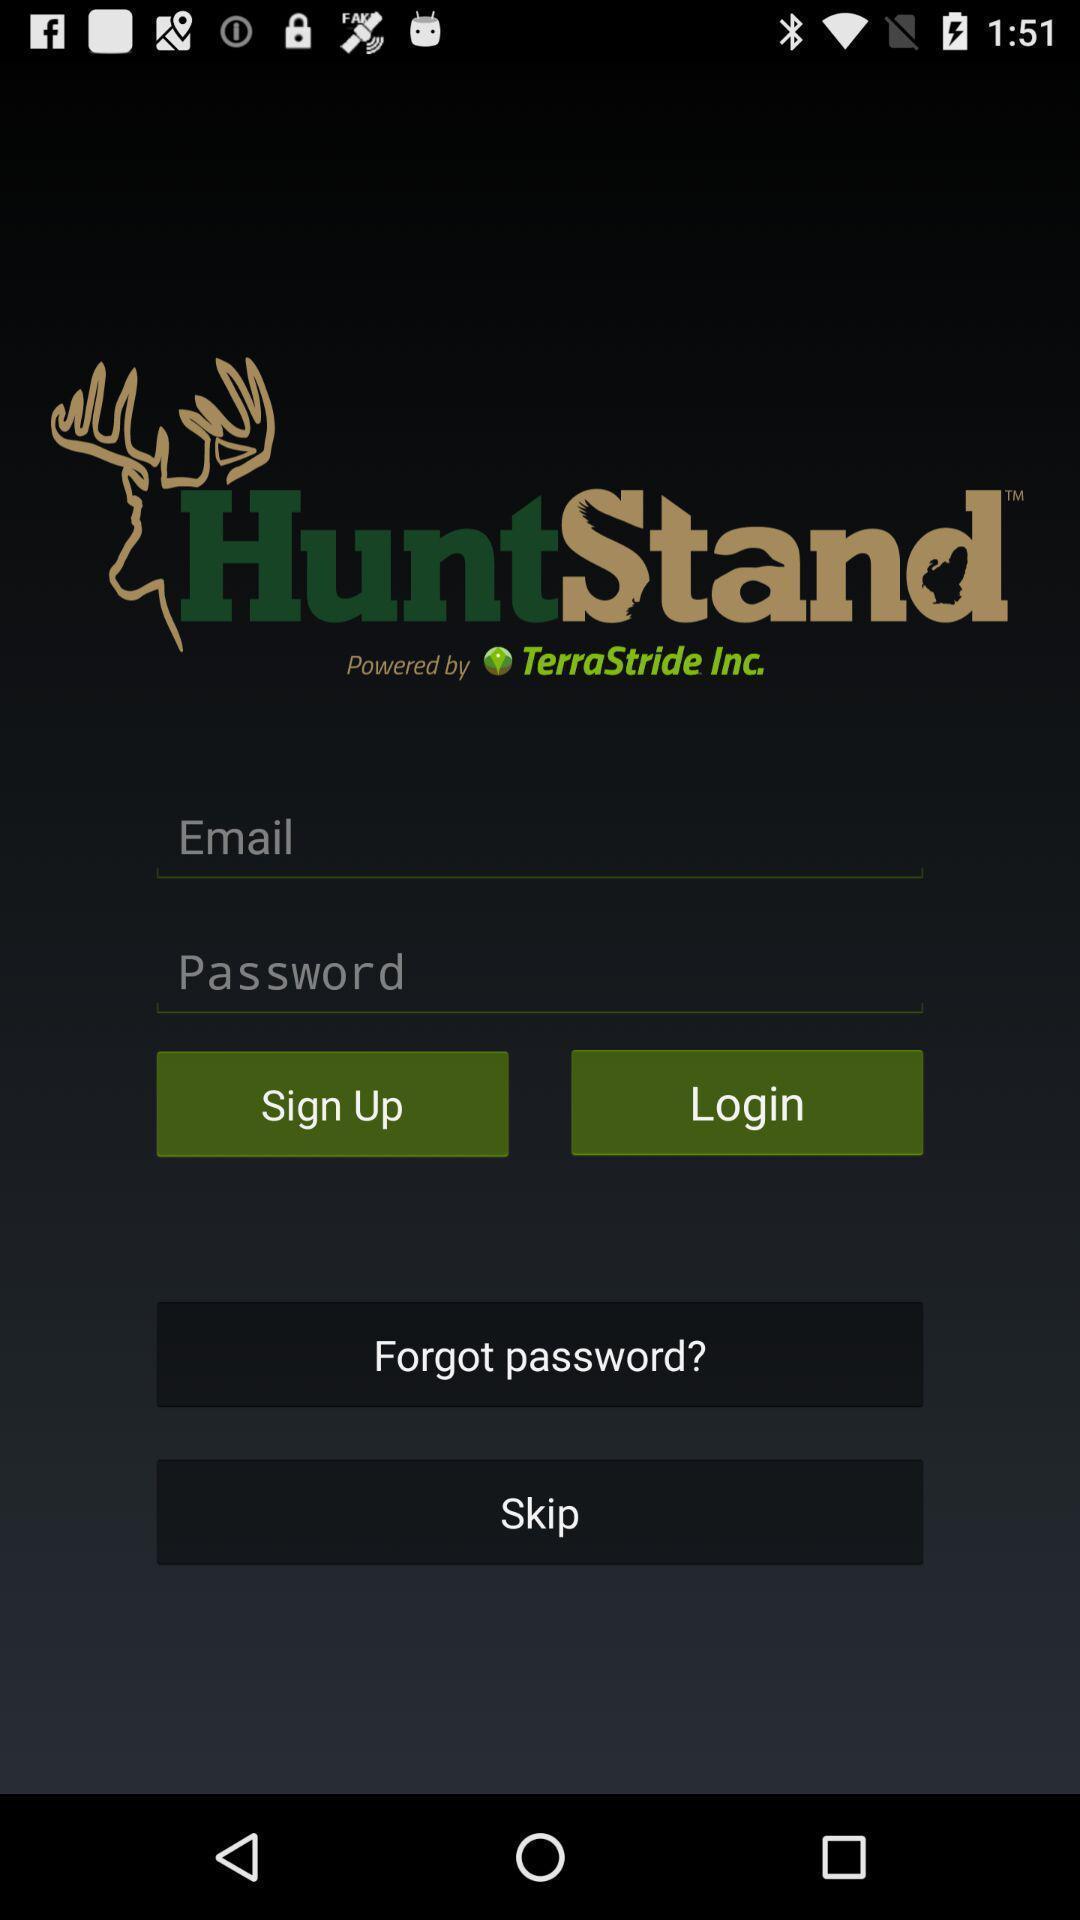Summarize the information in this screenshot. Sign in page. 